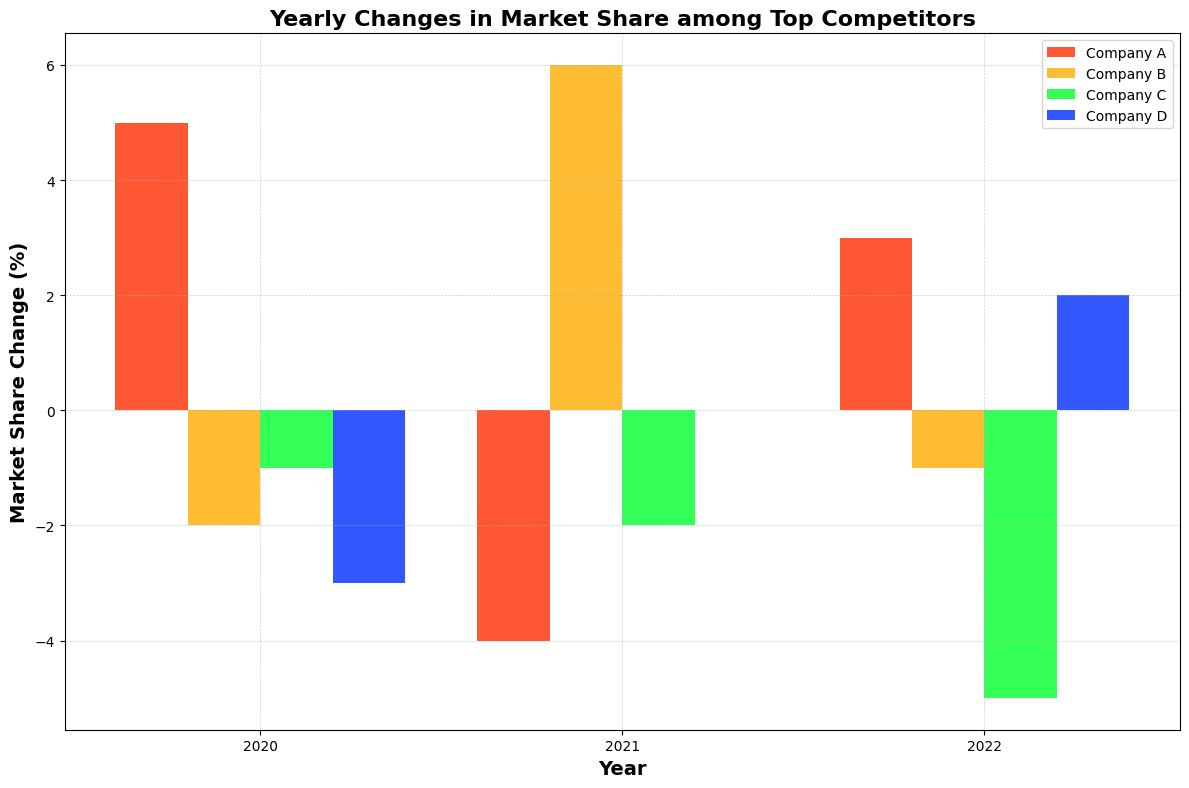What was the overall trend for Company A over the three years? From the chart, Company A's market share change started at +5% in 2020, dropped to -4% in 2021, and then rose to +3% in 2022. The trend shows fluctuations with an initial increase, a subsequent decrease, and then another increase.
Answer: Fluctuating with an overall positive tendency Which company had the highest increase in market share in any given year, and in which year did it occur? The chart shows that Company B had the highest increase of +6% in 2021.
Answer: Company B, 2021 How did Company D's market share change compare to Company C's in 2020? Company D had a market share change of -3%, while Company C had a market share change of -1% in 2020. Therefore, Company D's drop was 2 percentage points greater than Company C's.
Answer: Company D had a greater decrease Which year did all companies have both increases and decreases in market share changes? In 2021, Company A had a -4% change, Company B had a +6% change, Company C had a -2% change, and Company D had a 0% change. This year saw both increases and decreases across different companies.
Answer: 2021 What is the sum of market share changes for all companies in 2020? For 2020, summing the market share changes: 5 (Company A) + -2 (Company B) + -1 (Company C) + -3 (Company D) = 5 - 2 - 1 - 3 = -1.
Answer: -1 Between 2020 and 2021, which company showed the most dramatic change and by how much? Company A went from +5% in 2020 to -4% in 2021. The change is 5 - (-4) = 9 percentage points. This is the most dramatic change.
Answer: Company A, 9 percentage points Compare the market share change for Company B in 2020 and 2022. Which year was better for the company? In 2020, Company B had a -2% market share change, while in 2022, it had a -1% market share change. 2022 was better for the company as the negative impact was less.
Answer: 2022 Which company had no change in market share percentage in any year, and which year was it? Company D had no change in market share percentage in 2021, as indicated by a 0% change.
Answer: Company D, 2021 What is the average market share change for Company C across the three years? The market share changes for Company C are -1%, -2%, and -5% for the years 2020, 2021, and 2022, respectively. The average is calculated as (-1 + -2 + -5) / 3 = -8 / 3 ≈ -2.67%.
Answer: -2.67% In which year did three companies experience negative market share changes? In 2020, three companies (Company B, Company C, and Company D) experienced negative market share changes.
Answer: 2020 